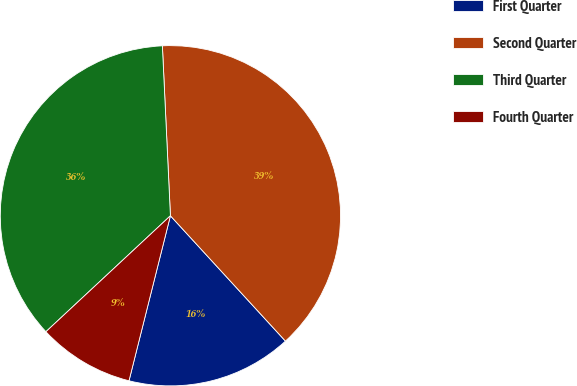<chart> <loc_0><loc_0><loc_500><loc_500><pie_chart><fcel>First Quarter<fcel>Second Quarter<fcel>Third Quarter<fcel>Fourth Quarter<nl><fcel>15.73%<fcel>38.93%<fcel>36.18%<fcel>9.15%<nl></chart> 